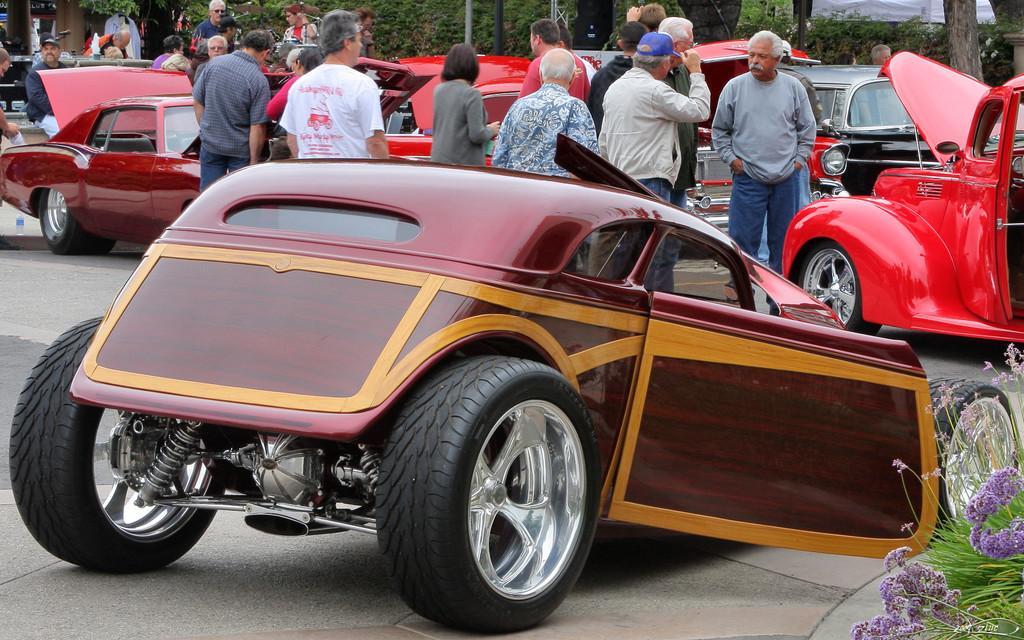How would you summarize this image in a sentence or two? In this picture there are some vehicles on the road. Few people are standing here. He wear a blue cap. There is a bottle. And on the background there are plants. Here these are the flowers. 